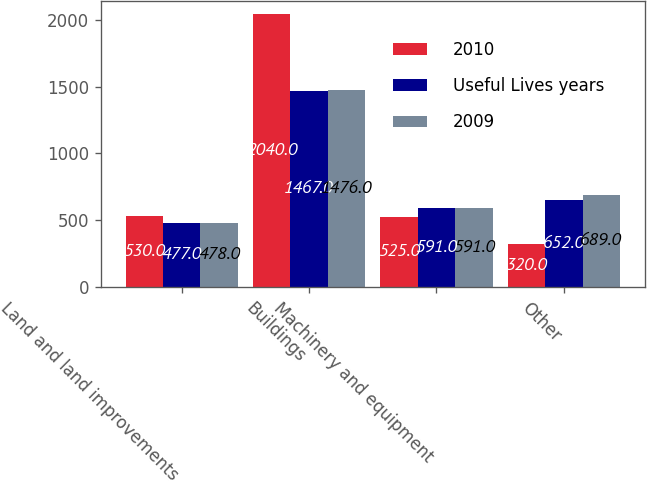Convert chart. <chart><loc_0><loc_0><loc_500><loc_500><stacked_bar_chart><ecel><fcel>Land and land improvements<fcel>Buildings<fcel>Machinery and equipment<fcel>Other<nl><fcel>2010<fcel>530<fcel>2040<fcel>525<fcel>320<nl><fcel>Useful Lives years<fcel>477<fcel>1467<fcel>591<fcel>652<nl><fcel>2009<fcel>478<fcel>1476<fcel>591<fcel>689<nl></chart> 